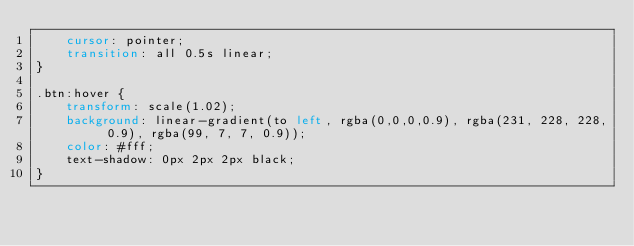<code> <loc_0><loc_0><loc_500><loc_500><_CSS_>    cursor: pointer;
    transition: all 0.5s linear;
}

.btn:hover {
    transform: scale(1.02);
    background: linear-gradient(to left, rgba(0,0,0,0.9), rgba(231, 228, 228, 0.9), rgba(99, 7, 7, 0.9));
    color: #fff;
    text-shadow: 0px 2px 2px black;
}
</code> 